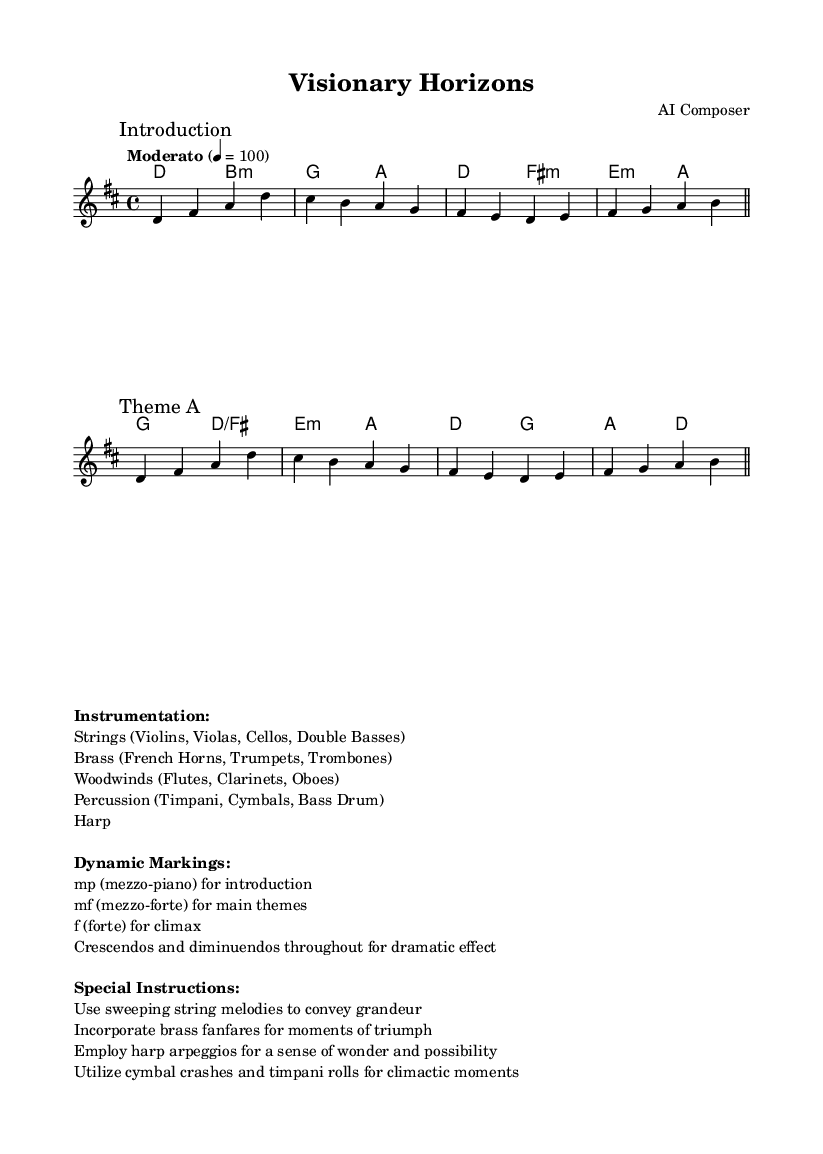What is the key signature of this music? The key signature is indicated at the beginning of the score. It shows two sharps, which corresponds to the notes F# and C#.
Answer: D major What is the time signature of this music? The time signature is found next to the key signature at the beginning of the score. It is written as 4/4, which means there are four beats in a measure and the quarter note gets one beat.
Answer: 4/4 What is the tempo marking for this composition? The tempo is specified above the staff in the first measure. It states "Moderato," which indicates a moderate speed of the music.
Answer: Moderato How many sections are there in the melody? The melody includes labeled sections, with "Introduction" and "Theme A" being specifically marked. By counting these, there are two distinct sections.
Answer: 2 What dynamic markings are used for the introduction? The dynamics for the introduction are noted in the markup section, indicating that the level is mezzo-piano, which translates to moderately soft.
Answer: mp Which instruments are specified for this composition? Instrumentation details are in the markup box of the score. It lists specific groups of instruments such as strings, brass, woodwinds, percussion, and harp.
Answer: Strings, Brass, Woodwinds, Percussion, Harp What role do crescendos play in this piece? The instructions mention using crescendos and diminuendos throughout for dramatic effect, indicating that they are meant to enhance the emotional intensity of the music.
Answer: Dramatic effect 